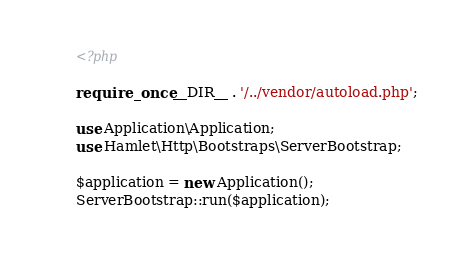Convert code to text. <code><loc_0><loc_0><loc_500><loc_500><_PHP_><?php

require_once __DIR__ . '/../vendor/autoload.php';

use Application\Application;
use Hamlet\Http\Bootstraps\ServerBootstrap;

$application = new Application();
ServerBootstrap::run($application);
</code> 